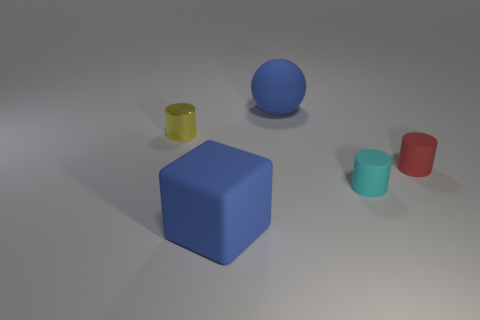There is a large object that is the same color as the ball; what shape is it?
Keep it short and to the point. Cube. There is a blue rubber thing that is behind the cyan object; how big is it?
Provide a short and direct response. Large. There is a yellow metal cylinder left of the small cyan matte thing; is it the same size as the blue thing that is in front of the big rubber sphere?
Provide a short and direct response. No. What number of other tiny objects have the same material as the small cyan thing?
Ensure brevity in your answer.  1. The metal cylinder is what color?
Provide a short and direct response. Yellow. There is a red rubber cylinder; are there any tiny metallic cylinders on the right side of it?
Offer a terse response. No. Is the large matte sphere the same color as the small shiny thing?
Give a very brief answer. No. How many small matte cylinders are the same color as the big ball?
Ensure brevity in your answer.  0. There is a blue thing in front of the big blue matte object behind the small metallic cylinder; what is its size?
Offer a terse response. Large. There is a big object right of the large blue matte block; what material is it?
Offer a terse response. Rubber. 